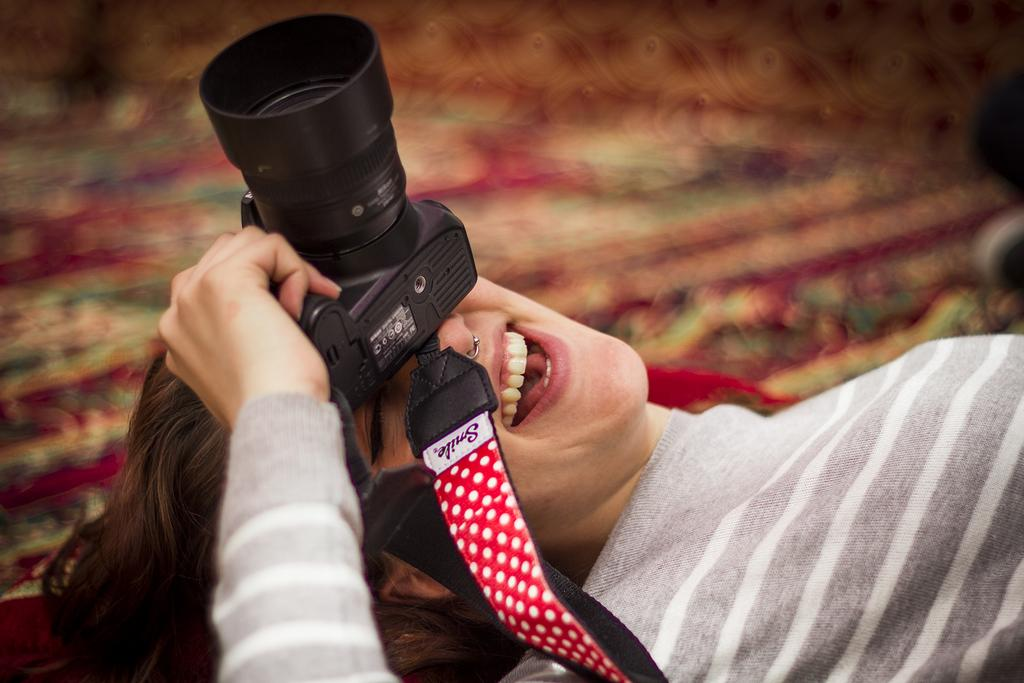Who is the main subject in the image? There is a girl in the image. What is the girl doing in the image? The girl is lying on the floor. What object is the girl holding in the image? The girl is holding a camera. What type of muscle is the girl exercising in the image? There is no muscle being exercised in the image; the girl is lying on the floor and holding a camera. 